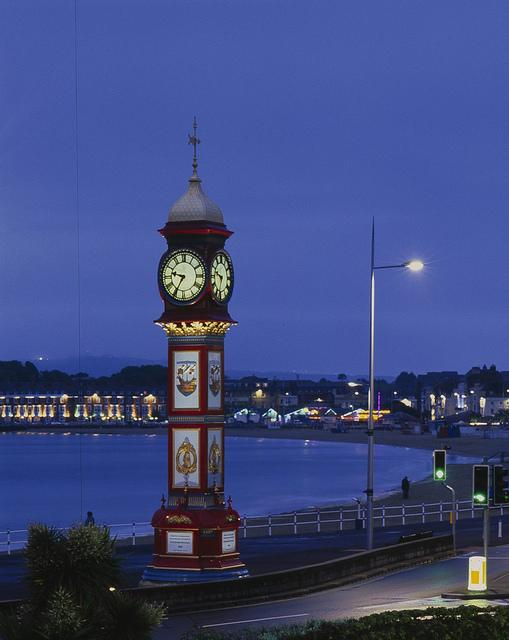What should traffic do by the light?

Choices:
A) move backwards
B) go
C) stop
D) yield go 